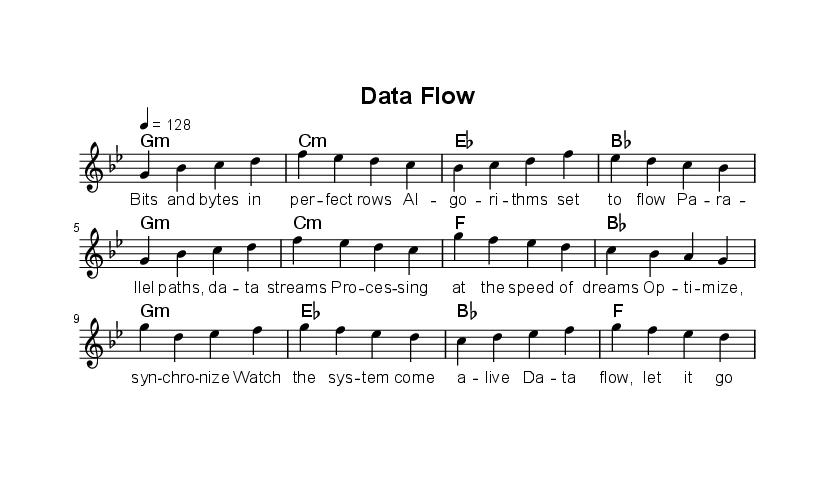What is the key signature of this music? The key signature is G minor, which contains two flats (B flat and E flat). This can be determined by looking at the key signature indicated at the beginning of the sheet music.
Answer: G minor What is the time signature of the piece? The time signature is 4/4, indicated at the beginning of the sheet music. This means there are four beats in each measure and the quarter note gets one beat.
Answer: 4/4 What is the tempo marking for this piece? The tempo marking is 128 BPM (beats per minute), as noted in the tempo indication. This means the piece should be played at a moderately fast pace.
Answer: 128 How many sections are there in the song? There are three sections in the song: Verse, Pre-Chorus, and Chorus, which can be identified by the distinct lyrics and designated segments in the sheet music.
Answer: Three Which chord is used in the chorus segment? The chords used in the chorus segment are G minor, E flat, B flat, and F, as listed under the harmonies where the chorus section's chords are noted.
Answer: G minor What is the primary theme of the lyrics? The primary theme of the lyrics revolves around data processing and algorithms, as the lyrics mention bits, bytes, algorithms, and digital concepts.
Answer: Data processing What musical genre does this piece belong to? This piece belongs to K-Pop, as indicated by the style, structure, and electronic beats inherent in the composition and lyrics.
Answer: K-Pop 